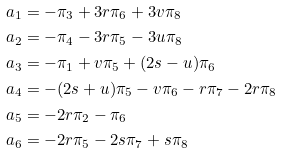<formula> <loc_0><loc_0><loc_500><loc_500>\ a _ { 1 } & = - \pi _ { 3 } + 3 r \pi _ { 6 } + 3 v \pi _ { 8 } \\ \ a _ { 2 } & = - \pi _ { 4 } - 3 r \pi _ { 5 } - 3 u \pi _ { 8 } \\ \ a _ { 3 } & = - \pi _ { 1 } + v \pi _ { 5 } + ( 2 s - u ) \pi _ { 6 } \\ \ a _ { 4 } & = - ( 2 s + u ) \pi _ { 5 } - v \pi _ { 6 } - r \pi _ { 7 } - 2 r \pi _ { 8 } \\ \ a _ { 5 } & = - 2 r \pi _ { 2 } - \pi _ { 6 } \\ \ a _ { 6 } & = - 2 r \pi _ { 5 } - 2 s \pi _ { 7 } + s \pi _ { 8 }</formula> 